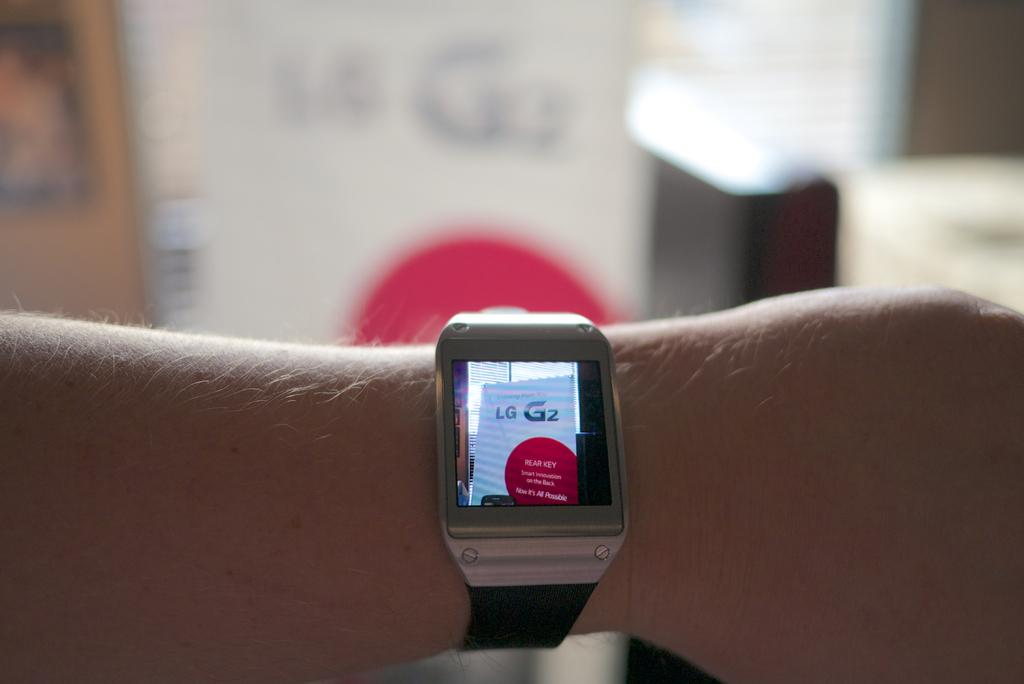<image>
Write a terse but informative summary of the picture. A person's watch displays the LG sign from across the room. 